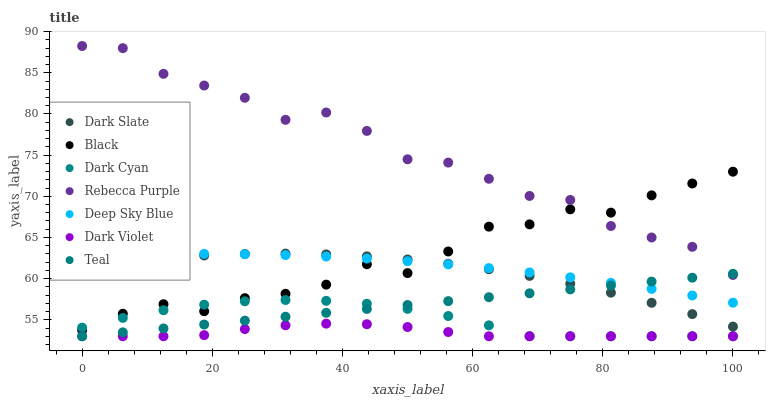Does Dark Violet have the minimum area under the curve?
Answer yes or no. Yes. Does Rebecca Purple have the maximum area under the curve?
Answer yes or no. Yes. Does Dark Slate have the minimum area under the curve?
Answer yes or no. No. Does Dark Slate have the maximum area under the curve?
Answer yes or no. No. Is Teal the smoothest?
Answer yes or no. Yes. Is Rebecca Purple the roughest?
Answer yes or no. Yes. Is Dark Violet the smoothest?
Answer yes or no. No. Is Dark Violet the roughest?
Answer yes or no. No. Does Teal have the lowest value?
Answer yes or no. Yes. Does Dark Slate have the lowest value?
Answer yes or no. No. Does Rebecca Purple have the highest value?
Answer yes or no. Yes. Does Dark Slate have the highest value?
Answer yes or no. No. Is Dark Violet less than Black?
Answer yes or no. Yes. Is Dark Slate greater than Dark Violet?
Answer yes or no. Yes. Does Dark Violet intersect Teal?
Answer yes or no. Yes. Is Dark Violet less than Teal?
Answer yes or no. No. Is Dark Violet greater than Teal?
Answer yes or no. No. Does Dark Violet intersect Black?
Answer yes or no. No. 